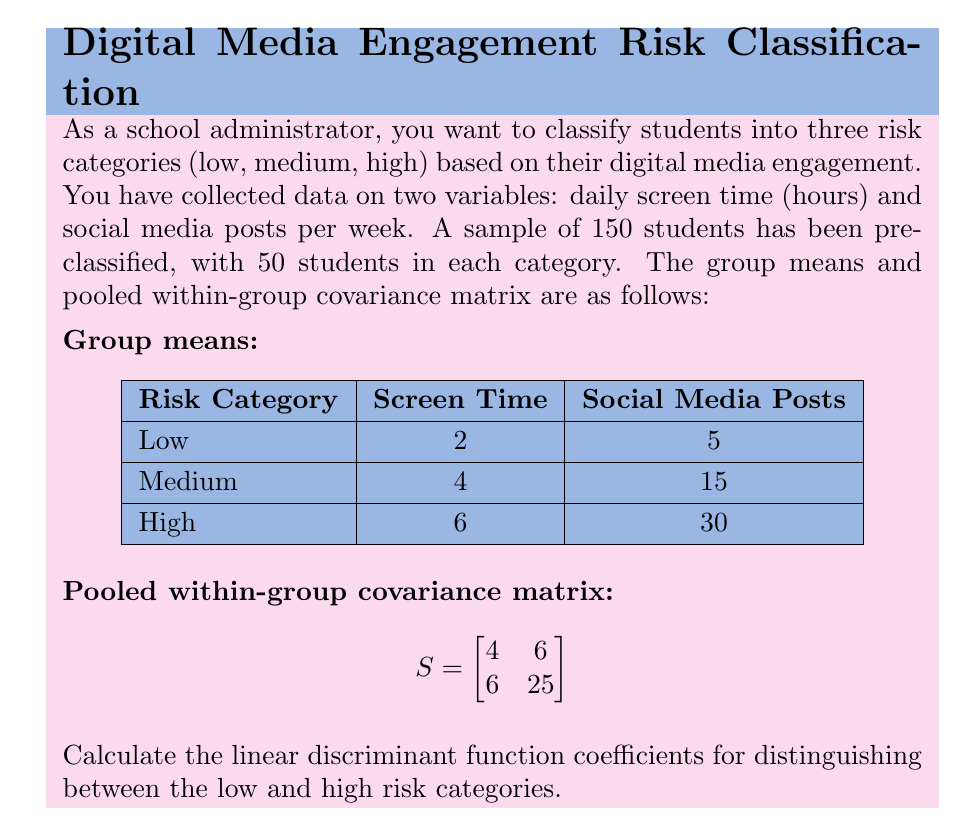Show me your answer to this math problem. To calculate the linear discriminant function coefficients, we'll follow these steps:

1) The linear discriminant function between two groups (1 and 2) is given by:
   $$a'x = (x̄_1 - x̄_2)'S^{-1}x$$

   where $a$ is the vector of coefficients we're looking for.

2) In our case, x̄_1 (low risk) and x̄_2 (high risk) are:
   $$x̄_1 = \begin{bmatrix} 2 \\ 5 \end{bmatrix}, \quad x̄_2 = \begin{bmatrix} 6 \\ 30 \end{bmatrix}$$

3) We need to calculate $S^{-1}$. The inverse of a 2x2 matrix $\begin{bmatrix} a & b \\ c & d \end{bmatrix}$ is:
   $$\frac{1}{ad-bc}\begin{bmatrix} d & -b \\ -c & a \end{bmatrix}$$

   For our $S$ matrix:
   $$S^{-1} = \frac{1}{4(25) - 6(6)}\begin{bmatrix} 25 & -6 \\ -6 & 4 \end{bmatrix} = \frac{1}{64}\begin{bmatrix} 25 & -6 \\ -6 & 4 \end{bmatrix}$$

4) Now we can calculate $a$:
   $$a = S^{-1}(x̄_1 - x̄_2) = \frac{1}{64}\begin{bmatrix} 25 & -6 \\ -6 & 4 \end{bmatrix}\begin{bmatrix} 2-6 \\ 5-30 \end{bmatrix} = \frac{1}{64}\begin{bmatrix} 25(-4) + (-6)(-25) \\ (-6)(-4) + 4(-25) \end{bmatrix}$$

5) Simplifying:
   $$a = \frac{1}{64}\begin{bmatrix} -100 + 150 \\ 24 - 100 \end{bmatrix} = \frac{1}{64}\begin{bmatrix} 50 \\ -76 \end{bmatrix} = \begin{bmatrix} 0.78125 \\ -1.1875 \end{bmatrix}$$

Therefore, the linear discriminant function is:
$$0.78125 \cdot \text{Screen Time} - 1.1875 \cdot \text{Social Media Posts}$$
Answer: $[0.78125, -1.1875]$ 